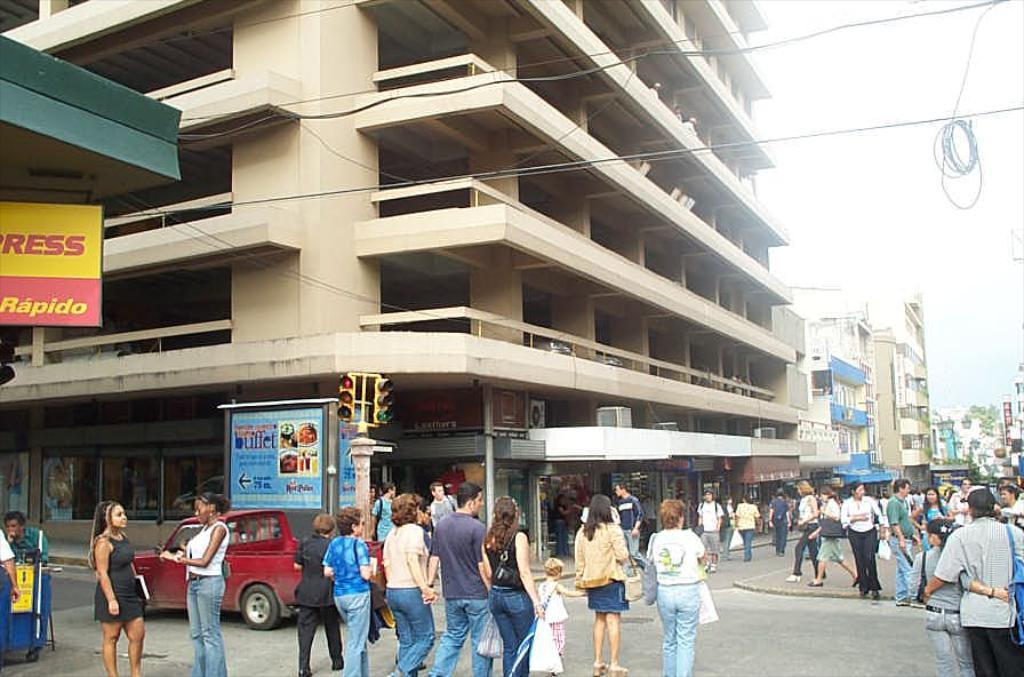How many people are in the image? There is a group of people in the image, but the exact number cannot be determined from the provided facts. What can be seen on the road in the image? There is a vehicle on the road in the image. What type of structures are visible in the image? There are buildings in the image. What are some objects that can be seen in the image? There are poles, traffic signals, boards, and hoardings in the image. What is visible in the background of the image? The sky is visible in the background of the image. What type of butter is being used to grease the poles in the image? There is no butter present in the image, and the poles are not being greased. What advice is being given to the people in the image? There is no indication of any advice being given in the image. 